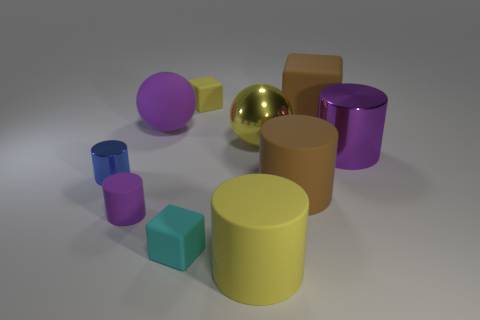What is the material of the ball that is the same color as the tiny matte cylinder?
Offer a terse response. Rubber. There is a metal cylinder on the right side of the small blue cylinder; does it have the same color as the small rubber cylinder?
Provide a succinct answer. Yes. What number of small objects are the same color as the tiny rubber cylinder?
Your response must be concise. 0. There is a small cube behind the tiny cyan object on the right side of the metal object in front of the purple metallic object; what is its material?
Your response must be concise. Rubber. What is the color of the rubber block in front of the large brown rubber object behind the brown cylinder?
Your response must be concise. Cyan. What number of small things are blue matte balls or cyan matte objects?
Your answer should be very brief. 1. What number of big things are the same material as the yellow cube?
Provide a succinct answer. 4. There is a purple cylinder on the left side of the large yellow matte object; what size is it?
Keep it short and to the point. Small. There is a large purple object that is on the right side of the large rubber object in front of the purple rubber cylinder; what is its shape?
Give a very brief answer. Cylinder. How many blue cylinders are right of the tiny matte thing left of the small matte block that is in front of the matte sphere?
Provide a succinct answer. 0. 